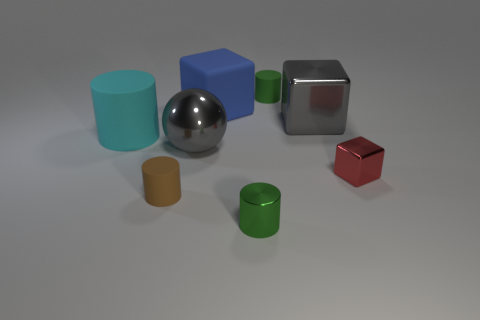Add 2 tiny blue matte spheres. How many objects exist? 10 Subtract all spheres. How many objects are left? 7 Subtract all large brown metallic blocks. Subtract all tiny green cylinders. How many objects are left? 6 Add 7 big shiny spheres. How many big shiny spheres are left? 8 Add 7 small brown rubber objects. How many small brown rubber objects exist? 8 Subtract 0 red balls. How many objects are left? 8 